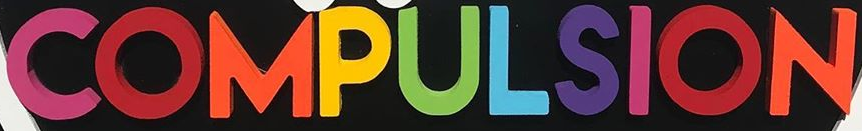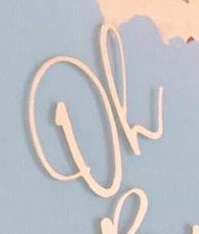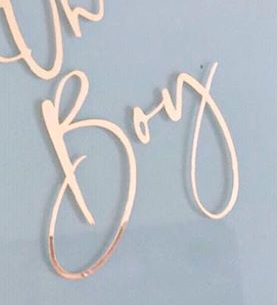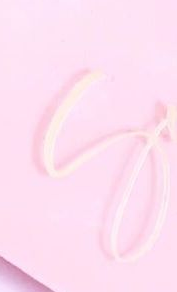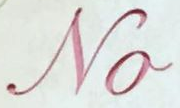Read the text content from these images in order, separated by a semicolon. COMPULSION; Oh; Boy; S; No 